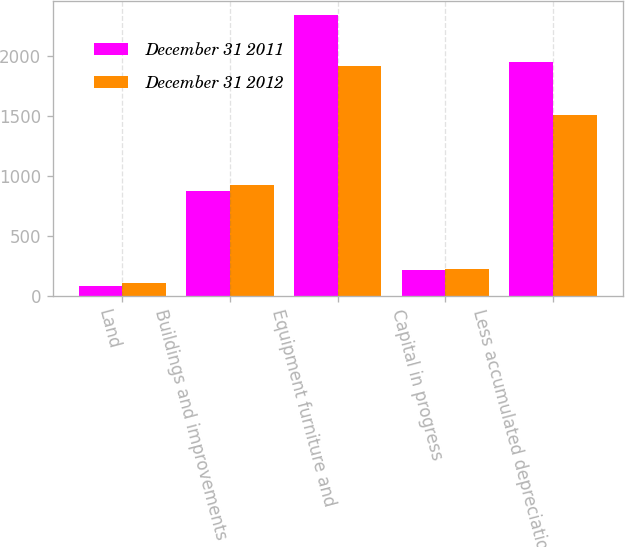Convert chart. <chart><loc_0><loc_0><loc_500><loc_500><stacked_bar_chart><ecel><fcel>Land<fcel>Buildings and improvements<fcel>Equipment furniture and<fcel>Capital in progress<fcel>Less accumulated depreciation<nl><fcel>December 31 2011<fcel>81<fcel>873<fcel>2348<fcel>218<fcel>1956<nl><fcel>December 31 2012<fcel>111<fcel>923<fcel>1919<fcel>230<fcel>1513<nl></chart> 